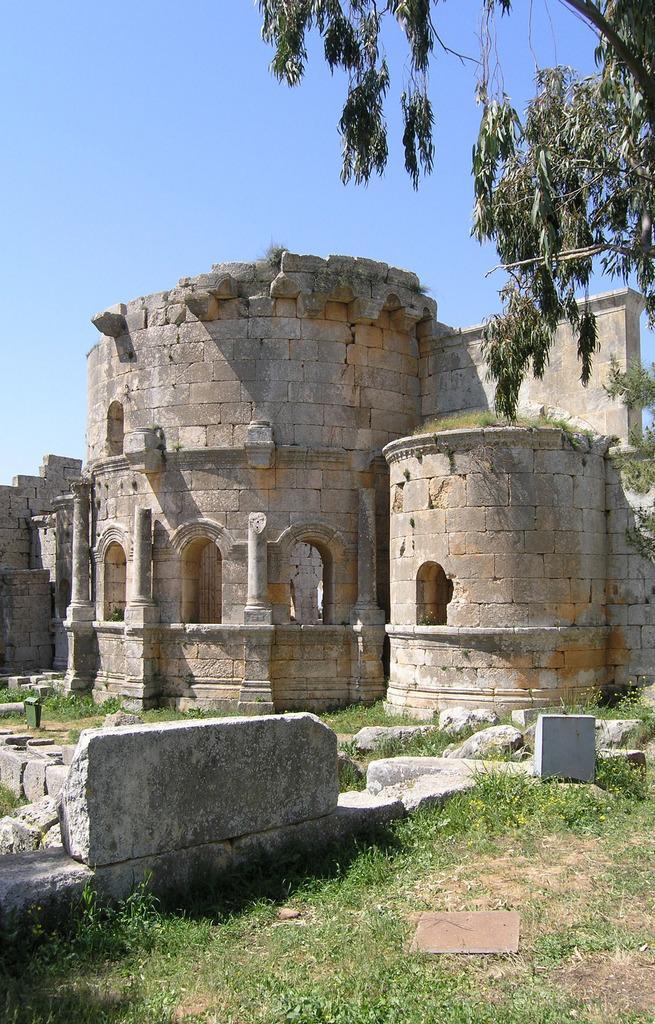Describe this image in one or two sentences. There is grass, stone building and a tree. 